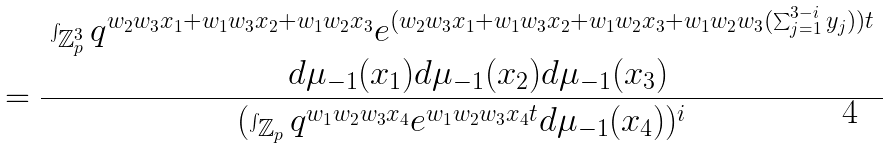Convert formula to latex. <formula><loc_0><loc_0><loc_500><loc_500>& = \frac { \begin{array} { c } \int _ { \mathbb { Z } _ { p } ^ { 3 } } q ^ { w _ { 2 } w _ { 3 } x _ { 1 } + w _ { 1 } w _ { 3 } x _ { 2 } + w _ { 1 } w _ { 2 } x _ { 3 } } e ^ { ( w _ { 2 } w _ { 3 } x _ { 1 } + w _ { 1 } w _ { 3 } x _ { 2 } + w _ { 1 } w _ { 2 } x _ { 3 } + w _ { 1 } w _ { 2 } w _ { 3 } ( \sum _ { j = 1 } ^ { 3 - i } y _ { j } ) ) t } \\ \quad d \mu _ { - 1 } ( x _ { 1 } ) d \mu _ { - 1 } ( x _ { 2 } ) d \mu _ { - 1 } ( x _ { 3 } ) \end{array} } { ( \int _ { \mathbb { Z } _ { p } } q ^ { w _ { 1 } w _ { 2 } w _ { 3 } x _ { 4 } } e ^ { w _ { 1 } w _ { 2 } w _ { 3 } x _ { 4 } t } d \mu _ { - 1 } ( x _ { 4 } ) ) ^ { i } }</formula> 